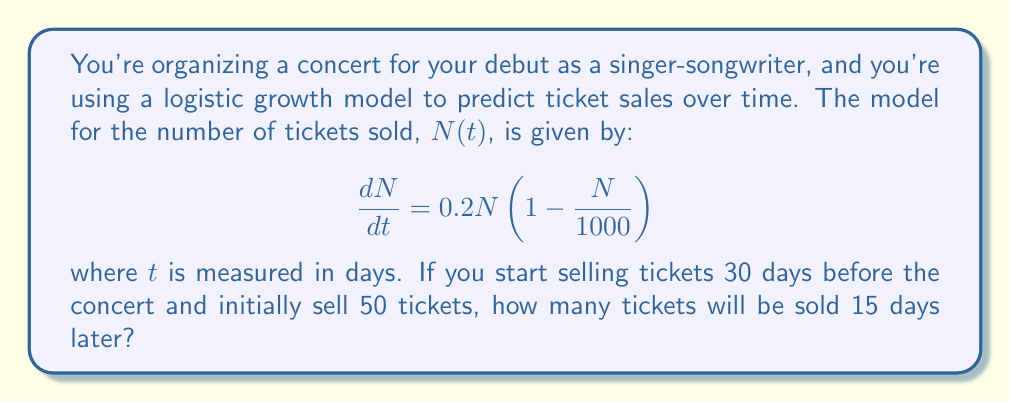Show me your answer to this math problem. To solve this problem, we need to use the logistic growth model and its solution. Let's approach this step-by-step:

1) The general solution to the logistic growth equation is:

   $$N(t) = \frac{K}{1 + \left(\frac{K}{N_0} - 1\right)e^{-rt}}$$

   where $K$ is the carrying capacity, $N_0$ is the initial population, and $r$ is the growth rate.

2) From the given equation, we can identify:
   $K = 1000$ (carrying capacity)
   $r = 0.2$ (growth rate)
   $N_0 = 50$ (initial number of tickets sold)

3) Substituting these values into the general solution:

   $$N(t) = \frac{1000}{1 + \left(\frac{1000}{50} - 1\right)e^{-0.2t}}$$

4) Simplify:
   
   $$N(t) = \frac{1000}{1 + 19e^{-0.2t}}$$

5) We want to find $N(15)$, so let's substitute $t = 15$:

   $$N(15) = \frac{1000}{1 + 19e^{-0.2(15)}}$$

6) Calculate:
   
   $$N(15) = \frac{1000}{1 + 19e^{-3}}$$
   $$N(15) = \frac{1000}{1 + 19(0.0497)}$$
   $$N(15) = \frac{1000}{1.9443}$$
   $$N(15) \approx 514.32$$

7) Since we can't sell a fraction of a ticket, we round down to the nearest whole number.
Answer: 514 tickets will be sold 15 days later. 